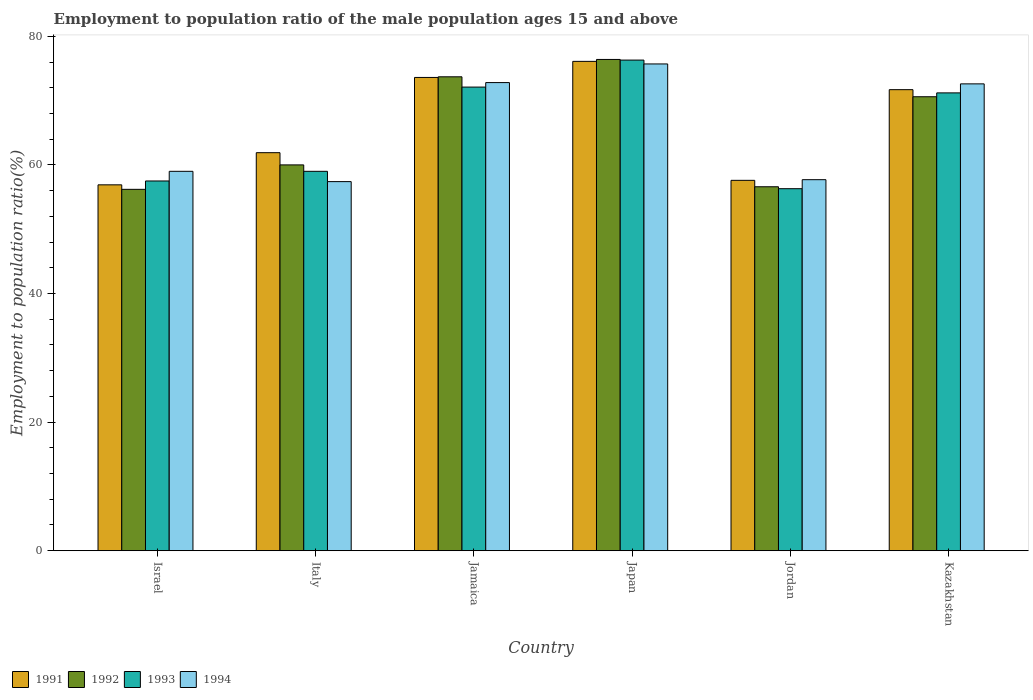How many different coloured bars are there?
Provide a succinct answer. 4. Are the number of bars per tick equal to the number of legend labels?
Make the answer very short. Yes. Are the number of bars on each tick of the X-axis equal?
Give a very brief answer. Yes. What is the label of the 6th group of bars from the left?
Keep it short and to the point. Kazakhstan. In how many cases, is the number of bars for a given country not equal to the number of legend labels?
Your answer should be compact. 0. What is the employment to population ratio in 1994 in Jamaica?
Ensure brevity in your answer.  72.8. Across all countries, what is the maximum employment to population ratio in 1991?
Give a very brief answer. 76.1. Across all countries, what is the minimum employment to population ratio in 1994?
Make the answer very short. 57.4. What is the total employment to population ratio in 1992 in the graph?
Your answer should be very brief. 393.5. What is the difference between the employment to population ratio in 1991 in Japan and that in Jordan?
Your response must be concise. 18.5. What is the difference between the employment to population ratio in 1991 in Kazakhstan and the employment to population ratio in 1993 in Italy?
Offer a terse response. 12.7. What is the average employment to population ratio in 1991 per country?
Your answer should be compact. 66.3. What is the difference between the employment to population ratio of/in 1992 and employment to population ratio of/in 1994 in Jamaica?
Your answer should be compact. 0.9. In how many countries, is the employment to population ratio in 1993 greater than 44 %?
Your answer should be compact. 6. What is the ratio of the employment to population ratio in 1993 in Italy to that in Japan?
Offer a terse response. 0.77. Is the employment to population ratio in 1993 in Israel less than that in Jordan?
Offer a very short reply. No. Is the difference between the employment to population ratio in 1992 in Jamaica and Japan greater than the difference between the employment to population ratio in 1994 in Jamaica and Japan?
Keep it short and to the point. Yes. What is the difference between the highest and the second highest employment to population ratio in 1994?
Your response must be concise. 0.2. What is the difference between the highest and the lowest employment to population ratio in 1992?
Your answer should be compact. 20.2. In how many countries, is the employment to population ratio in 1991 greater than the average employment to population ratio in 1991 taken over all countries?
Provide a short and direct response. 3. Is the sum of the employment to population ratio in 1992 in Japan and Jordan greater than the maximum employment to population ratio in 1994 across all countries?
Your answer should be compact. Yes. What does the 2nd bar from the right in Jamaica represents?
Offer a very short reply. 1993. Is it the case that in every country, the sum of the employment to population ratio in 1992 and employment to population ratio in 1994 is greater than the employment to population ratio in 1991?
Ensure brevity in your answer.  Yes. How many bars are there?
Provide a succinct answer. 24. What is the difference between two consecutive major ticks on the Y-axis?
Ensure brevity in your answer.  20. Are the values on the major ticks of Y-axis written in scientific E-notation?
Your answer should be compact. No. Does the graph contain any zero values?
Keep it short and to the point. No. Where does the legend appear in the graph?
Provide a succinct answer. Bottom left. How many legend labels are there?
Your answer should be compact. 4. How are the legend labels stacked?
Your answer should be compact. Horizontal. What is the title of the graph?
Your answer should be very brief. Employment to population ratio of the male population ages 15 and above. Does "1989" appear as one of the legend labels in the graph?
Provide a short and direct response. No. What is the label or title of the Y-axis?
Your answer should be very brief. Employment to population ratio(%). What is the Employment to population ratio(%) of 1991 in Israel?
Offer a terse response. 56.9. What is the Employment to population ratio(%) in 1992 in Israel?
Your answer should be compact. 56.2. What is the Employment to population ratio(%) of 1993 in Israel?
Give a very brief answer. 57.5. What is the Employment to population ratio(%) in 1994 in Israel?
Keep it short and to the point. 59. What is the Employment to population ratio(%) in 1991 in Italy?
Your answer should be very brief. 61.9. What is the Employment to population ratio(%) of 1992 in Italy?
Provide a short and direct response. 60. What is the Employment to population ratio(%) in 1994 in Italy?
Make the answer very short. 57.4. What is the Employment to population ratio(%) in 1991 in Jamaica?
Give a very brief answer. 73.6. What is the Employment to population ratio(%) in 1992 in Jamaica?
Offer a very short reply. 73.7. What is the Employment to population ratio(%) in 1993 in Jamaica?
Offer a terse response. 72.1. What is the Employment to population ratio(%) of 1994 in Jamaica?
Offer a terse response. 72.8. What is the Employment to population ratio(%) of 1991 in Japan?
Keep it short and to the point. 76.1. What is the Employment to population ratio(%) in 1992 in Japan?
Your answer should be compact. 76.4. What is the Employment to population ratio(%) of 1993 in Japan?
Your answer should be very brief. 76.3. What is the Employment to population ratio(%) of 1994 in Japan?
Your answer should be very brief. 75.7. What is the Employment to population ratio(%) of 1991 in Jordan?
Give a very brief answer. 57.6. What is the Employment to population ratio(%) of 1992 in Jordan?
Your answer should be very brief. 56.6. What is the Employment to population ratio(%) of 1993 in Jordan?
Give a very brief answer. 56.3. What is the Employment to population ratio(%) of 1994 in Jordan?
Offer a terse response. 57.7. What is the Employment to population ratio(%) in 1991 in Kazakhstan?
Give a very brief answer. 71.7. What is the Employment to population ratio(%) of 1992 in Kazakhstan?
Make the answer very short. 70.6. What is the Employment to population ratio(%) in 1993 in Kazakhstan?
Ensure brevity in your answer.  71.2. What is the Employment to population ratio(%) of 1994 in Kazakhstan?
Your response must be concise. 72.6. Across all countries, what is the maximum Employment to population ratio(%) of 1991?
Your response must be concise. 76.1. Across all countries, what is the maximum Employment to population ratio(%) in 1992?
Provide a succinct answer. 76.4. Across all countries, what is the maximum Employment to population ratio(%) of 1993?
Give a very brief answer. 76.3. Across all countries, what is the maximum Employment to population ratio(%) in 1994?
Provide a short and direct response. 75.7. Across all countries, what is the minimum Employment to population ratio(%) of 1991?
Your answer should be very brief. 56.9. Across all countries, what is the minimum Employment to population ratio(%) of 1992?
Ensure brevity in your answer.  56.2. Across all countries, what is the minimum Employment to population ratio(%) of 1993?
Provide a succinct answer. 56.3. Across all countries, what is the minimum Employment to population ratio(%) of 1994?
Your answer should be very brief. 57.4. What is the total Employment to population ratio(%) in 1991 in the graph?
Your answer should be compact. 397.8. What is the total Employment to population ratio(%) in 1992 in the graph?
Provide a succinct answer. 393.5. What is the total Employment to population ratio(%) in 1993 in the graph?
Provide a succinct answer. 392.4. What is the total Employment to population ratio(%) of 1994 in the graph?
Give a very brief answer. 395.2. What is the difference between the Employment to population ratio(%) of 1993 in Israel and that in Italy?
Make the answer very short. -1.5. What is the difference between the Employment to population ratio(%) of 1994 in Israel and that in Italy?
Make the answer very short. 1.6. What is the difference between the Employment to population ratio(%) of 1991 in Israel and that in Jamaica?
Give a very brief answer. -16.7. What is the difference between the Employment to population ratio(%) of 1992 in Israel and that in Jamaica?
Provide a short and direct response. -17.5. What is the difference between the Employment to population ratio(%) of 1993 in Israel and that in Jamaica?
Give a very brief answer. -14.6. What is the difference between the Employment to population ratio(%) in 1991 in Israel and that in Japan?
Offer a terse response. -19.2. What is the difference between the Employment to population ratio(%) in 1992 in Israel and that in Japan?
Provide a short and direct response. -20.2. What is the difference between the Employment to population ratio(%) in 1993 in Israel and that in Japan?
Your response must be concise. -18.8. What is the difference between the Employment to population ratio(%) in 1994 in Israel and that in Japan?
Ensure brevity in your answer.  -16.7. What is the difference between the Employment to population ratio(%) of 1992 in Israel and that in Jordan?
Provide a short and direct response. -0.4. What is the difference between the Employment to population ratio(%) in 1993 in Israel and that in Jordan?
Make the answer very short. 1.2. What is the difference between the Employment to population ratio(%) in 1991 in Israel and that in Kazakhstan?
Provide a short and direct response. -14.8. What is the difference between the Employment to population ratio(%) in 1992 in Israel and that in Kazakhstan?
Offer a terse response. -14.4. What is the difference between the Employment to population ratio(%) of 1993 in Israel and that in Kazakhstan?
Your answer should be very brief. -13.7. What is the difference between the Employment to population ratio(%) in 1992 in Italy and that in Jamaica?
Offer a very short reply. -13.7. What is the difference between the Employment to population ratio(%) of 1994 in Italy and that in Jamaica?
Offer a very short reply. -15.4. What is the difference between the Employment to population ratio(%) in 1991 in Italy and that in Japan?
Provide a succinct answer. -14.2. What is the difference between the Employment to population ratio(%) in 1992 in Italy and that in Japan?
Ensure brevity in your answer.  -16.4. What is the difference between the Employment to population ratio(%) in 1993 in Italy and that in Japan?
Your response must be concise. -17.3. What is the difference between the Employment to population ratio(%) in 1994 in Italy and that in Japan?
Your answer should be compact. -18.3. What is the difference between the Employment to population ratio(%) in 1992 in Italy and that in Jordan?
Make the answer very short. 3.4. What is the difference between the Employment to population ratio(%) of 1993 in Italy and that in Jordan?
Provide a succinct answer. 2.7. What is the difference between the Employment to population ratio(%) of 1994 in Italy and that in Jordan?
Provide a succinct answer. -0.3. What is the difference between the Employment to population ratio(%) in 1994 in Italy and that in Kazakhstan?
Provide a short and direct response. -15.2. What is the difference between the Employment to population ratio(%) of 1992 in Jamaica and that in Japan?
Your answer should be very brief. -2.7. What is the difference between the Employment to population ratio(%) in 1993 in Jamaica and that in Japan?
Your answer should be compact. -4.2. What is the difference between the Employment to population ratio(%) in 1993 in Jamaica and that in Jordan?
Your answer should be compact. 15.8. What is the difference between the Employment to population ratio(%) of 1994 in Jamaica and that in Jordan?
Ensure brevity in your answer.  15.1. What is the difference between the Employment to population ratio(%) of 1991 in Jamaica and that in Kazakhstan?
Give a very brief answer. 1.9. What is the difference between the Employment to population ratio(%) in 1994 in Jamaica and that in Kazakhstan?
Offer a very short reply. 0.2. What is the difference between the Employment to population ratio(%) of 1992 in Japan and that in Jordan?
Give a very brief answer. 19.8. What is the difference between the Employment to population ratio(%) of 1994 in Japan and that in Jordan?
Keep it short and to the point. 18. What is the difference between the Employment to population ratio(%) of 1991 in Japan and that in Kazakhstan?
Give a very brief answer. 4.4. What is the difference between the Employment to population ratio(%) of 1992 in Japan and that in Kazakhstan?
Give a very brief answer. 5.8. What is the difference between the Employment to population ratio(%) of 1991 in Jordan and that in Kazakhstan?
Your answer should be compact. -14.1. What is the difference between the Employment to population ratio(%) in 1993 in Jordan and that in Kazakhstan?
Provide a short and direct response. -14.9. What is the difference between the Employment to population ratio(%) in 1994 in Jordan and that in Kazakhstan?
Provide a succinct answer. -14.9. What is the difference between the Employment to population ratio(%) of 1991 in Israel and the Employment to population ratio(%) of 1992 in Italy?
Keep it short and to the point. -3.1. What is the difference between the Employment to population ratio(%) of 1991 in Israel and the Employment to population ratio(%) of 1993 in Italy?
Provide a short and direct response. -2.1. What is the difference between the Employment to population ratio(%) of 1993 in Israel and the Employment to population ratio(%) of 1994 in Italy?
Give a very brief answer. 0.1. What is the difference between the Employment to population ratio(%) of 1991 in Israel and the Employment to population ratio(%) of 1992 in Jamaica?
Your answer should be very brief. -16.8. What is the difference between the Employment to population ratio(%) in 1991 in Israel and the Employment to population ratio(%) in 1993 in Jamaica?
Your answer should be compact. -15.2. What is the difference between the Employment to population ratio(%) in 1991 in Israel and the Employment to population ratio(%) in 1994 in Jamaica?
Provide a short and direct response. -15.9. What is the difference between the Employment to population ratio(%) of 1992 in Israel and the Employment to population ratio(%) of 1993 in Jamaica?
Provide a succinct answer. -15.9. What is the difference between the Employment to population ratio(%) in 1992 in Israel and the Employment to population ratio(%) in 1994 in Jamaica?
Provide a succinct answer. -16.6. What is the difference between the Employment to population ratio(%) of 1993 in Israel and the Employment to population ratio(%) of 1994 in Jamaica?
Ensure brevity in your answer.  -15.3. What is the difference between the Employment to population ratio(%) in 1991 in Israel and the Employment to population ratio(%) in 1992 in Japan?
Your answer should be compact. -19.5. What is the difference between the Employment to population ratio(%) in 1991 in Israel and the Employment to population ratio(%) in 1993 in Japan?
Your answer should be compact. -19.4. What is the difference between the Employment to population ratio(%) in 1991 in Israel and the Employment to population ratio(%) in 1994 in Japan?
Provide a succinct answer. -18.8. What is the difference between the Employment to population ratio(%) in 1992 in Israel and the Employment to population ratio(%) in 1993 in Japan?
Ensure brevity in your answer.  -20.1. What is the difference between the Employment to population ratio(%) in 1992 in Israel and the Employment to population ratio(%) in 1994 in Japan?
Ensure brevity in your answer.  -19.5. What is the difference between the Employment to population ratio(%) in 1993 in Israel and the Employment to population ratio(%) in 1994 in Japan?
Ensure brevity in your answer.  -18.2. What is the difference between the Employment to population ratio(%) of 1991 in Israel and the Employment to population ratio(%) of 1992 in Jordan?
Make the answer very short. 0.3. What is the difference between the Employment to population ratio(%) in 1992 in Israel and the Employment to population ratio(%) in 1994 in Jordan?
Keep it short and to the point. -1.5. What is the difference between the Employment to population ratio(%) in 1993 in Israel and the Employment to population ratio(%) in 1994 in Jordan?
Provide a succinct answer. -0.2. What is the difference between the Employment to population ratio(%) in 1991 in Israel and the Employment to population ratio(%) in 1992 in Kazakhstan?
Provide a short and direct response. -13.7. What is the difference between the Employment to population ratio(%) in 1991 in Israel and the Employment to population ratio(%) in 1993 in Kazakhstan?
Ensure brevity in your answer.  -14.3. What is the difference between the Employment to population ratio(%) of 1991 in Israel and the Employment to population ratio(%) of 1994 in Kazakhstan?
Ensure brevity in your answer.  -15.7. What is the difference between the Employment to population ratio(%) of 1992 in Israel and the Employment to population ratio(%) of 1994 in Kazakhstan?
Keep it short and to the point. -16.4. What is the difference between the Employment to population ratio(%) of 1993 in Israel and the Employment to population ratio(%) of 1994 in Kazakhstan?
Provide a succinct answer. -15.1. What is the difference between the Employment to population ratio(%) of 1991 in Italy and the Employment to population ratio(%) of 1993 in Jamaica?
Provide a succinct answer. -10.2. What is the difference between the Employment to population ratio(%) of 1991 in Italy and the Employment to population ratio(%) of 1994 in Jamaica?
Your response must be concise. -10.9. What is the difference between the Employment to population ratio(%) of 1992 in Italy and the Employment to population ratio(%) of 1993 in Jamaica?
Provide a short and direct response. -12.1. What is the difference between the Employment to population ratio(%) of 1992 in Italy and the Employment to population ratio(%) of 1994 in Jamaica?
Your answer should be very brief. -12.8. What is the difference between the Employment to population ratio(%) of 1991 in Italy and the Employment to population ratio(%) of 1993 in Japan?
Offer a terse response. -14.4. What is the difference between the Employment to population ratio(%) of 1992 in Italy and the Employment to population ratio(%) of 1993 in Japan?
Your answer should be compact. -16.3. What is the difference between the Employment to population ratio(%) in 1992 in Italy and the Employment to population ratio(%) in 1994 in Japan?
Keep it short and to the point. -15.7. What is the difference between the Employment to population ratio(%) in 1993 in Italy and the Employment to population ratio(%) in 1994 in Japan?
Your answer should be very brief. -16.7. What is the difference between the Employment to population ratio(%) of 1991 in Italy and the Employment to population ratio(%) of 1992 in Jordan?
Your answer should be very brief. 5.3. What is the difference between the Employment to population ratio(%) of 1991 in Italy and the Employment to population ratio(%) of 1993 in Jordan?
Make the answer very short. 5.6. What is the difference between the Employment to population ratio(%) of 1992 in Italy and the Employment to population ratio(%) of 1994 in Jordan?
Provide a succinct answer. 2.3. What is the difference between the Employment to population ratio(%) in 1993 in Italy and the Employment to population ratio(%) in 1994 in Jordan?
Your response must be concise. 1.3. What is the difference between the Employment to population ratio(%) in 1991 in Italy and the Employment to population ratio(%) in 1992 in Kazakhstan?
Keep it short and to the point. -8.7. What is the difference between the Employment to population ratio(%) of 1991 in Italy and the Employment to population ratio(%) of 1994 in Kazakhstan?
Provide a short and direct response. -10.7. What is the difference between the Employment to population ratio(%) of 1992 in Italy and the Employment to population ratio(%) of 1993 in Kazakhstan?
Ensure brevity in your answer.  -11.2. What is the difference between the Employment to population ratio(%) in 1991 in Jamaica and the Employment to population ratio(%) in 1993 in Japan?
Your answer should be very brief. -2.7. What is the difference between the Employment to population ratio(%) of 1992 in Jamaica and the Employment to population ratio(%) of 1994 in Japan?
Provide a short and direct response. -2. What is the difference between the Employment to population ratio(%) in 1991 in Jamaica and the Employment to population ratio(%) in 1993 in Jordan?
Your answer should be very brief. 17.3. What is the difference between the Employment to population ratio(%) in 1991 in Jamaica and the Employment to population ratio(%) in 1993 in Kazakhstan?
Keep it short and to the point. 2.4. What is the difference between the Employment to population ratio(%) in 1991 in Jamaica and the Employment to population ratio(%) in 1994 in Kazakhstan?
Offer a terse response. 1. What is the difference between the Employment to population ratio(%) of 1992 in Jamaica and the Employment to population ratio(%) of 1993 in Kazakhstan?
Provide a succinct answer. 2.5. What is the difference between the Employment to population ratio(%) of 1992 in Jamaica and the Employment to population ratio(%) of 1994 in Kazakhstan?
Your answer should be very brief. 1.1. What is the difference between the Employment to population ratio(%) of 1991 in Japan and the Employment to population ratio(%) of 1993 in Jordan?
Provide a succinct answer. 19.8. What is the difference between the Employment to population ratio(%) of 1991 in Japan and the Employment to population ratio(%) of 1994 in Jordan?
Your answer should be compact. 18.4. What is the difference between the Employment to population ratio(%) of 1992 in Japan and the Employment to population ratio(%) of 1993 in Jordan?
Your response must be concise. 20.1. What is the difference between the Employment to population ratio(%) in 1993 in Japan and the Employment to population ratio(%) in 1994 in Jordan?
Your answer should be very brief. 18.6. What is the difference between the Employment to population ratio(%) of 1991 in Japan and the Employment to population ratio(%) of 1992 in Kazakhstan?
Offer a very short reply. 5.5. What is the difference between the Employment to population ratio(%) of 1991 in Japan and the Employment to population ratio(%) of 1993 in Kazakhstan?
Your answer should be compact. 4.9. What is the difference between the Employment to population ratio(%) in 1992 in Japan and the Employment to population ratio(%) in 1994 in Kazakhstan?
Offer a very short reply. 3.8. What is the difference between the Employment to population ratio(%) in 1993 in Japan and the Employment to population ratio(%) in 1994 in Kazakhstan?
Your answer should be very brief. 3.7. What is the difference between the Employment to population ratio(%) in 1991 in Jordan and the Employment to population ratio(%) in 1992 in Kazakhstan?
Provide a short and direct response. -13. What is the difference between the Employment to population ratio(%) in 1991 in Jordan and the Employment to population ratio(%) in 1994 in Kazakhstan?
Offer a very short reply. -15. What is the difference between the Employment to population ratio(%) of 1992 in Jordan and the Employment to population ratio(%) of 1993 in Kazakhstan?
Ensure brevity in your answer.  -14.6. What is the difference between the Employment to population ratio(%) of 1993 in Jordan and the Employment to population ratio(%) of 1994 in Kazakhstan?
Your answer should be compact. -16.3. What is the average Employment to population ratio(%) in 1991 per country?
Provide a succinct answer. 66.3. What is the average Employment to population ratio(%) of 1992 per country?
Your response must be concise. 65.58. What is the average Employment to population ratio(%) of 1993 per country?
Ensure brevity in your answer.  65.4. What is the average Employment to population ratio(%) in 1994 per country?
Your answer should be very brief. 65.87. What is the difference between the Employment to population ratio(%) in 1991 and Employment to population ratio(%) in 1993 in Israel?
Give a very brief answer. -0.6. What is the difference between the Employment to population ratio(%) of 1991 and Employment to population ratio(%) of 1994 in Israel?
Keep it short and to the point. -2.1. What is the difference between the Employment to population ratio(%) of 1992 and Employment to population ratio(%) of 1994 in Israel?
Your answer should be compact. -2.8. What is the difference between the Employment to population ratio(%) of 1992 and Employment to population ratio(%) of 1993 in Italy?
Your answer should be compact. 1. What is the difference between the Employment to population ratio(%) in 1993 and Employment to population ratio(%) in 1994 in Italy?
Provide a short and direct response. 1.6. What is the difference between the Employment to population ratio(%) in 1993 and Employment to population ratio(%) in 1994 in Jamaica?
Provide a succinct answer. -0.7. What is the difference between the Employment to population ratio(%) of 1991 and Employment to population ratio(%) of 1994 in Japan?
Provide a succinct answer. 0.4. What is the difference between the Employment to population ratio(%) of 1992 and Employment to population ratio(%) of 1993 in Japan?
Give a very brief answer. 0.1. What is the difference between the Employment to population ratio(%) in 1993 and Employment to population ratio(%) in 1994 in Japan?
Make the answer very short. 0.6. What is the difference between the Employment to population ratio(%) in 1991 and Employment to population ratio(%) in 1993 in Jordan?
Your answer should be very brief. 1.3. What is the difference between the Employment to population ratio(%) of 1991 and Employment to population ratio(%) of 1994 in Jordan?
Your answer should be very brief. -0.1. What is the difference between the Employment to population ratio(%) of 1992 and Employment to population ratio(%) of 1993 in Jordan?
Make the answer very short. 0.3. What is the difference between the Employment to population ratio(%) in 1992 and Employment to population ratio(%) in 1994 in Jordan?
Keep it short and to the point. -1.1. What is the difference between the Employment to population ratio(%) of 1993 and Employment to population ratio(%) of 1994 in Jordan?
Your answer should be very brief. -1.4. What is the difference between the Employment to population ratio(%) of 1991 and Employment to population ratio(%) of 1992 in Kazakhstan?
Your answer should be very brief. 1.1. What is the difference between the Employment to population ratio(%) of 1991 and Employment to population ratio(%) of 1993 in Kazakhstan?
Provide a succinct answer. 0.5. What is the difference between the Employment to population ratio(%) of 1991 and Employment to population ratio(%) of 1994 in Kazakhstan?
Offer a very short reply. -0.9. What is the difference between the Employment to population ratio(%) of 1992 and Employment to population ratio(%) of 1993 in Kazakhstan?
Your answer should be compact. -0.6. What is the ratio of the Employment to population ratio(%) in 1991 in Israel to that in Italy?
Your answer should be compact. 0.92. What is the ratio of the Employment to population ratio(%) of 1992 in Israel to that in Italy?
Offer a terse response. 0.94. What is the ratio of the Employment to population ratio(%) in 1993 in Israel to that in Italy?
Your answer should be very brief. 0.97. What is the ratio of the Employment to population ratio(%) of 1994 in Israel to that in Italy?
Give a very brief answer. 1.03. What is the ratio of the Employment to population ratio(%) in 1991 in Israel to that in Jamaica?
Your answer should be compact. 0.77. What is the ratio of the Employment to population ratio(%) in 1992 in Israel to that in Jamaica?
Your response must be concise. 0.76. What is the ratio of the Employment to population ratio(%) of 1993 in Israel to that in Jamaica?
Keep it short and to the point. 0.8. What is the ratio of the Employment to population ratio(%) in 1994 in Israel to that in Jamaica?
Give a very brief answer. 0.81. What is the ratio of the Employment to population ratio(%) of 1991 in Israel to that in Japan?
Keep it short and to the point. 0.75. What is the ratio of the Employment to population ratio(%) of 1992 in Israel to that in Japan?
Provide a succinct answer. 0.74. What is the ratio of the Employment to population ratio(%) of 1993 in Israel to that in Japan?
Keep it short and to the point. 0.75. What is the ratio of the Employment to population ratio(%) in 1994 in Israel to that in Japan?
Your answer should be very brief. 0.78. What is the ratio of the Employment to population ratio(%) of 1991 in Israel to that in Jordan?
Your answer should be compact. 0.99. What is the ratio of the Employment to population ratio(%) in 1993 in Israel to that in Jordan?
Ensure brevity in your answer.  1.02. What is the ratio of the Employment to population ratio(%) in 1994 in Israel to that in Jordan?
Provide a short and direct response. 1.02. What is the ratio of the Employment to population ratio(%) of 1991 in Israel to that in Kazakhstan?
Provide a succinct answer. 0.79. What is the ratio of the Employment to population ratio(%) of 1992 in Israel to that in Kazakhstan?
Provide a short and direct response. 0.8. What is the ratio of the Employment to population ratio(%) in 1993 in Israel to that in Kazakhstan?
Provide a succinct answer. 0.81. What is the ratio of the Employment to population ratio(%) of 1994 in Israel to that in Kazakhstan?
Give a very brief answer. 0.81. What is the ratio of the Employment to population ratio(%) in 1991 in Italy to that in Jamaica?
Provide a succinct answer. 0.84. What is the ratio of the Employment to population ratio(%) of 1992 in Italy to that in Jamaica?
Provide a succinct answer. 0.81. What is the ratio of the Employment to population ratio(%) in 1993 in Italy to that in Jamaica?
Your answer should be compact. 0.82. What is the ratio of the Employment to population ratio(%) of 1994 in Italy to that in Jamaica?
Offer a very short reply. 0.79. What is the ratio of the Employment to population ratio(%) of 1991 in Italy to that in Japan?
Give a very brief answer. 0.81. What is the ratio of the Employment to population ratio(%) of 1992 in Italy to that in Japan?
Give a very brief answer. 0.79. What is the ratio of the Employment to population ratio(%) of 1993 in Italy to that in Japan?
Your answer should be compact. 0.77. What is the ratio of the Employment to population ratio(%) of 1994 in Italy to that in Japan?
Give a very brief answer. 0.76. What is the ratio of the Employment to population ratio(%) in 1991 in Italy to that in Jordan?
Your response must be concise. 1.07. What is the ratio of the Employment to population ratio(%) in 1992 in Italy to that in Jordan?
Provide a short and direct response. 1.06. What is the ratio of the Employment to population ratio(%) of 1993 in Italy to that in Jordan?
Keep it short and to the point. 1.05. What is the ratio of the Employment to population ratio(%) in 1994 in Italy to that in Jordan?
Offer a terse response. 0.99. What is the ratio of the Employment to population ratio(%) of 1991 in Italy to that in Kazakhstan?
Your answer should be compact. 0.86. What is the ratio of the Employment to population ratio(%) in 1992 in Italy to that in Kazakhstan?
Your answer should be very brief. 0.85. What is the ratio of the Employment to population ratio(%) in 1993 in Italy to that in Kazakhstan?
Offer a terse response. 0.83. What is the ratio of the Employment to population ratio(%) of 1994 in Italy to that in Kazakhstan?
Provide a succinct answer. 0.79. What is the ratio of the Employment to population ratio(%) in 1991 in Jamaica to that in Japan?
Give a very brief answer. 0.97. What is the ratio of the Employment to population ratio(%) in 1992 in Jamaica to that in Japan?
Ensure brevity in your answer.  0.96. What is the ratio of the Employment to population ratio(%) in 1993 in Jamaica to that in Japan?
Your answer should be compact. 0.94. What is the ratio of the Employment to population ratio(%) in 1994 in Jamaica to that in Japan?
Your answer should be compact. 0.96. What is the ratio of the Employment to population ratio(%) of 1991 in Jamaica to that in Jordan?
Offer a very short reply. 1.28. What is the ratio of the Employment to population ratio(%) in 1992 in Jamaica to that in Jordan?
Offer a terse response. 1.3. What is the ratio of the Employment to population ratio(%) of 1993 in Jamaica to that in Jordan?
Your answer should be very brief. 1.28. What is the ratio of the Employment to population ratio(%) of 1994 in Jamaica to that in Jordan?
Your response must be concise. 1.26. What is the ratio of the Employment to population ratio(%) in 1991 in Jamaica to that in Kazakhstan?
Keep it short and to the point. 1.03. What is the ratio of the Employment to population ratio(%) in 1992 in Jamaica to that in Kazakhstan?
Your answer should be compact. 1.04. What is the ratio of the Employment to population ratio(%) in 1993 in Jamaica to that in Kazakhstan?
Your answer should be very brief. 1.01. What is the ratio of the Employment to population ratio(%) in 1994 in Jamaica to that in Kazakhstan?
Your answer should be compact. 1. What is the ratio of the Employment to population ratio(%) of 1991 in Japan to that in Jordan?
Offer a terse response. 1.32. What is the ratio of the Employment to population ratio(%) of 1992 in Japan to that in Jordan?
Offer a terse response. 1.35. What is the ratio of the Employment to population ratio(%) of 1993 in Japan to that in Jordan?
Provide a succinct answer. 1.36. What is the ratio of the Employment to population ratio(%) in 1994 in Japan to that in Jordan?
Make the answer very short. 1.31. What is the ratio of the Employment to population ratio(%) in 1991 in Japan to that in Kazakhstan?
Your answer should be very brief. 1.06. What is the ratio of the Employment to population ratio(%) in 1992 in Japan to that in Kazakhstan?
Make the answer very short. 1.08. What is the ratio of the Employment to population ratio(%) in 1993 in Japan to that in Kazakhstan?
Keep it short and to the point. 1.07. What is the ratio of the Employment to population ratio(%) in 1994 in Japan to that in Kazakhstan?
Offer a terse response. 1.04. What is the ratio of the Employment to population ratio(%) of 1991 in Jordan to that in Kazakhstan?
Ensure brevity in your answer.  0.8. What is the ratio of the Employment to population ratio(%) in 1992 in Jordan to that in Kazakhstan?
Make the answer very short. 0.8. What is the ratio of the Employment to population ratio(%) of 1993 in Jordan to that in Kazakhstan?
Your answer should be very brief. 0.79. What is the ratio of the Employment to population ratio(%) in 1994 in Jordan to that in Kazakhstan?
Provide a short and direct response. 0.79. What is the difference between the highest and the second highest Employment to population ratio(%) in 1991?
Provide a succinct answer. 2.5. What is the difference between the highest and the second highest Employment to population ratio(%) of 1992?
Keep it short and to the point. 2.7. What is the difference between the highest and the second highest Employment to population ratio(%) of 1994?
Give a very brief answer. 2.9. What is the difference between the highest and the lowest Employment to population ratio(%) in 1992?
Offer a terse response. 20.2. What is the difference between the highest and the lowest Employment to population ratio(%) in 1993?
Offer a very short reply. 20. What is the difference between the highest and the lowest Employment to population ratio(%) in 1994?
Make the answer very short. 18.3. 